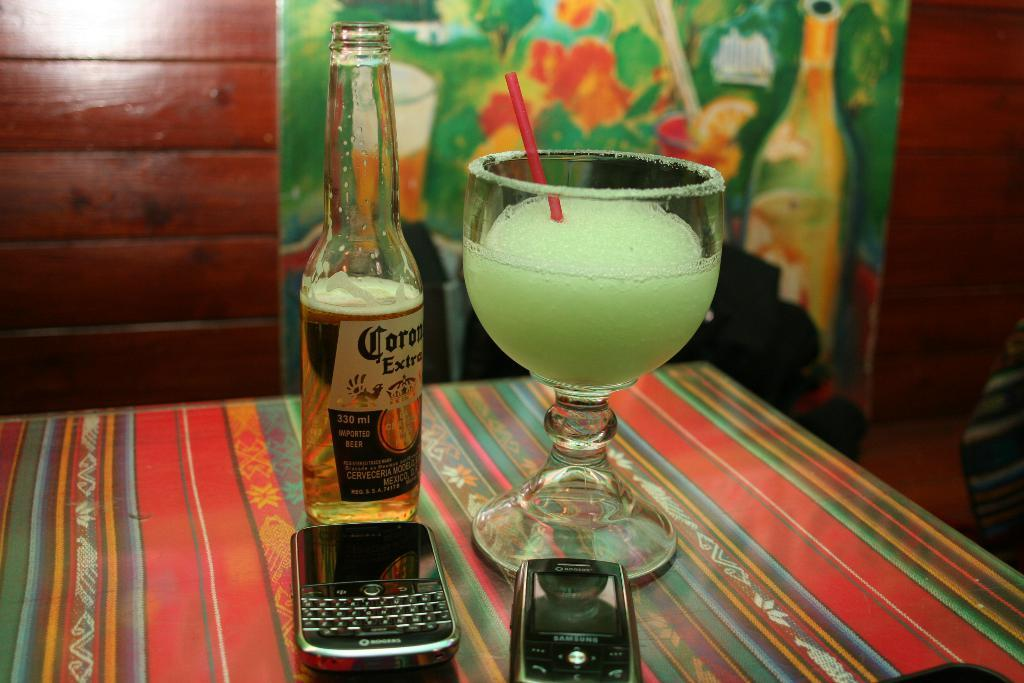Provide a one-sentence caption for the provided image. A bottle of Corona beer next to a glass of pale green liquid. 